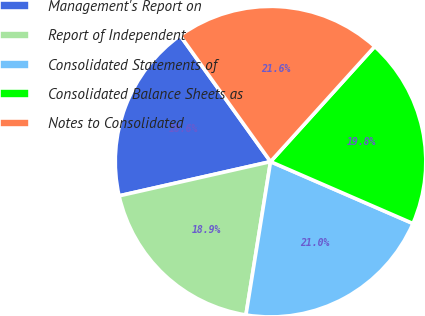Convert chart to OTSL. <chart><loc_0><loc_0><loc_500><loc_500><pie_chart><fcel>Management's Report on<fcel>Report of Independent<fcel>Consolidated Statements of<fcel>Consolidated Balance Sheets as<fcel>Notes to Consolidated<nl><fcel>18.64%<fcel>18.93%<fcel>21.01%<fcel>19.82%<fcel>21.6%<nl></chart> 